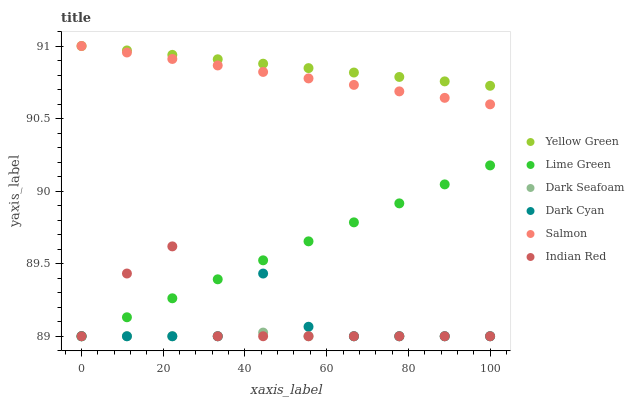Does Dark Seafoam have the minimum area under the curve?
Answer yes or no. Yes. Does Yellow Green have the maximum area under the curve?
Answer yes or no. Yes. Does Salmon have the minimum area under the curve?
Answer yes or no. No. Does Salmon have the maximum area under the curve?
Answer yes or no. No. Is Salmon the smoothest?
Answer yes or no. Yes. Is Indian Red the roughest?
Answer yes or no. Yes. Is Dark Seafoam the smoothest?
Answer yes or no. No. Is Dark Seafoam the roughest?
Answer yes or no. No. Does Dark Seafoam have the lowest value?
Answer yes or no. Yes. Does Salmon have the lowest value?
Answer yes or no. No. Does Salmon have the highest value?
Answer yes or no. Yes. Does Dark Seafoam have the highest value?
Answer yes or no. No. Is Lime Green less than Salmon?
Answer yes or no. Yes. Is Salmon greater than Lime Green?
Answer yes or no. Yes. Does Dark Seafoam intersect Indian Red?
Answer yes or no. Yes. Is Dark Seafoam less than Indian Red?
Answer yes or no. No. Is Dark Seafoam greater than Indian Red?
Answer yes or no. No. Does Lime Green intersect Salmon?
Answer yes or no. No. 